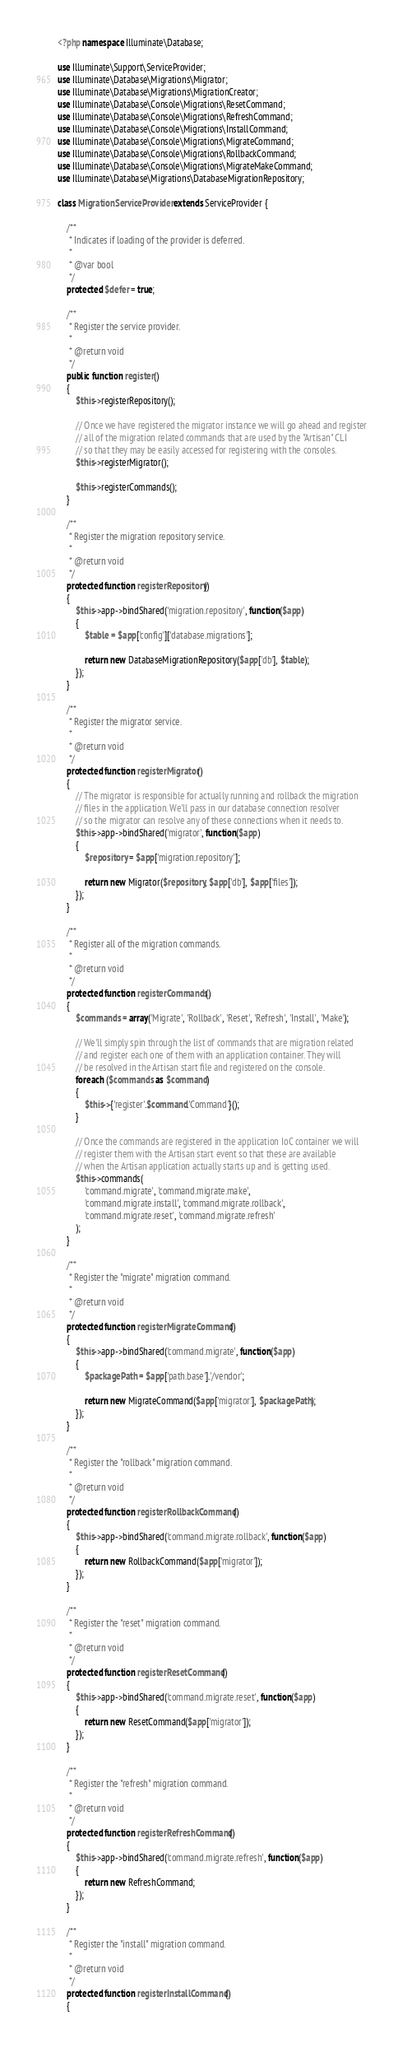<code> <loc_0><loc_0><loc_500><loc_500><_PHP_><?php namespace Illuminate\Database;

use Illuminate\Support\ServiceProvider;
use Illuminate\Database\Migrations\Migrator;
use Illuminate\Database\Migrations\MigrationCreator;
use Illuminate\Database\Console\Migrations\ResetCommand;
use Illuminate\Database\Console\Migrations\RefreshCommand;
use Illuminate\Database\Console\Migrations\InstallCommand;
use Illuminate\Database\Console\Migrations\MigrateCommand;
use Illuminate\Database\Console\Migrations\RollbackCommand;
use Illuminate\Database\Console\Migrations\MigrateMakeCommand;
use Illuminate\Database\Migrations\DatabaseMigrationRepository;

class MigrationServiceProvider extends ServiceProvider {

	/**
	 * Indicates if loading of the provider is deferred.
	 *
	 * @var bool
	 */
	protected $defer = true;

	/**
	 * Register the service provider.
	 *
	 * @return void
	 */
	public function register()
	{
		$this->registerRepository();

		// Once we have registered the migrator instance we will go ahead and register
		// all of the migration related commands that are used by the "Artisan" CLI
		// so that they may be easily accessed for registering with the consoles.
		$this->registerMigrator();

		$this->registerCommands();
	}

	/**
	 * Register the migration repository service.
	 *
	 * @return void
	 */
	protected function registerRepository()
	{
		$this->app->bindShared('migration.repository', function($app)
		{
			$table = $app['config']['database.migrations'];

			return new DatabaseMigrationRepository($app['db'], $table);
		});
	}

	/**
	 * Register the migrator service.
	 *
	 * @return void
	 */
	protected function registerMigrator()
	{
		// The migrator is responsible for actually running and rollback the migration
		// files in the application. We'll pass in our database connection resolver
		// so the migrator can resolve any of these connections when it needs to.
		$this->app->bindShared('migrator', function($app)
		{
			$repository = $app['migration.repository'];

			return new Migrator($repository, $app['db'], $app['files']);
		});
	}

	/**
	 * Register all of the migration commands.
	 *
	 * @return void
	 */
	protected function registerCommands()
	{
		$commands = array('Migrate', 'Rollback', 'Reset', 'Refresh', 'Install', 'Make');

		// We'll simply spin through the list of commands that are migration related
		// and register each one of them with an application container. They will
		// be resolved in the Artisan start file and registered on the console.
		foreach ($commands as $command)
		{
			$this->{'register'.$command.'Command'}();
		}

		// Once the commands are registered in the application IoC container we will
		// register them with the Artisan start event so that these are available
		// when the Artisan application actually starts up and is getting used.
		$this->commands(
			'command.migrate', 'command.migrate.make',
			'command.migrate.install', 'command.migrate.rollback',
			'command.migrate.reset', 'command.migrate.refresh'
		);
	}

	/**
	 * Register the "migrate" migration command.
	 *
	 * @return void
	 */
	protected function registerMigrateCommand()
	{
		$this->app->bindShared('command.migrate', function($app)
		{
			$packagePath = $app['path.base'].'/vendor';

			return new MigrateCommand($app['migrator'], $packagePath);
		});
	}

	/**
	 * Register the "rollback" migration command.
	 *
	 * @return void
	 */
	protected function registerRollbackCommand()
	{
		$this->app->bindShared('command.migrate.rollback', function($app)
		{
			return new RollbackCommand($app['migrator']);
		});
	}

	/**
	 * Register the "reset" migration command.
	 *
	 * @return void
	 */
	protected function registerResetCommand()
	{
		$this->app->bindShared('command.migrate.reset', function($app)
		{
			return new ResetCommand($app['migrator']);
		});
	}

	/**
	 * Register the "refresh" migration command.
	 *
	 * @return void
	 */
	protected function registerRefreshCommand()
	{
		$this->app->bindShared('command.migrate.refresh', function($app)
		{
			return new RefreshCommand;
		});
	}

	/**
	 * Register the "install" migration command.
	 *
	 * @return void
	 */
	protected function registerInstallCommand()
	{</code> 